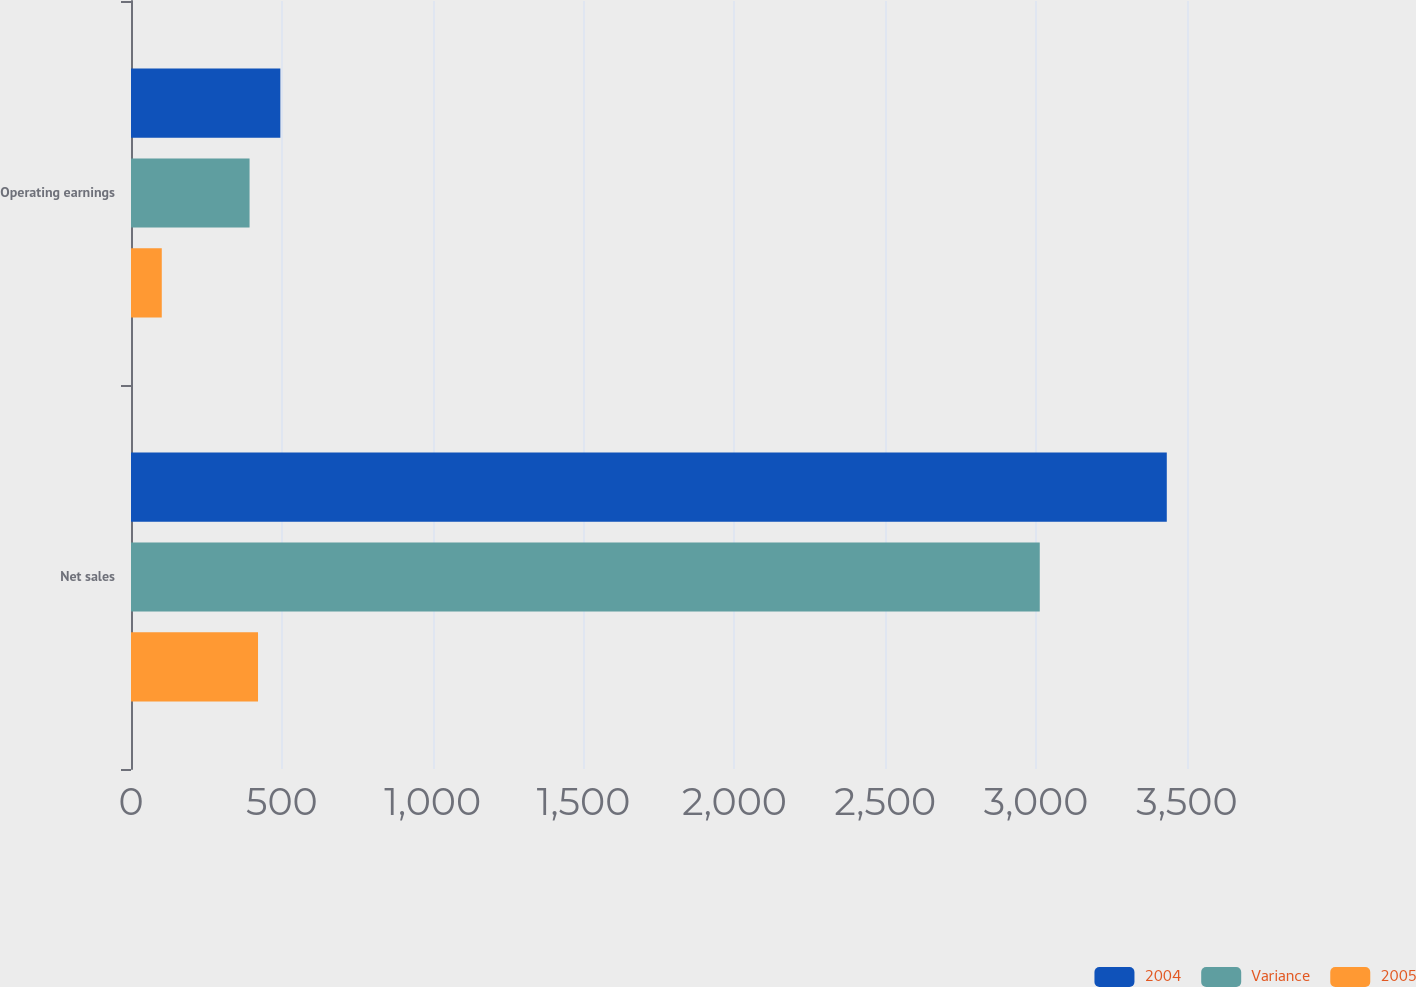Convert chart to OTSL. <chart><loc_0><loc_0><loc_500><loc_500><stacked_bar_chart><ecel><fcel>Net sales<fcel>Operating earnings<nl><fcel>2004<fcel>3433<fcel>495<nl><fcel>Variance<fcel>3012<fcel>393<nl><fcel>2005<fcel>421<fcel>102<nl></chart> 